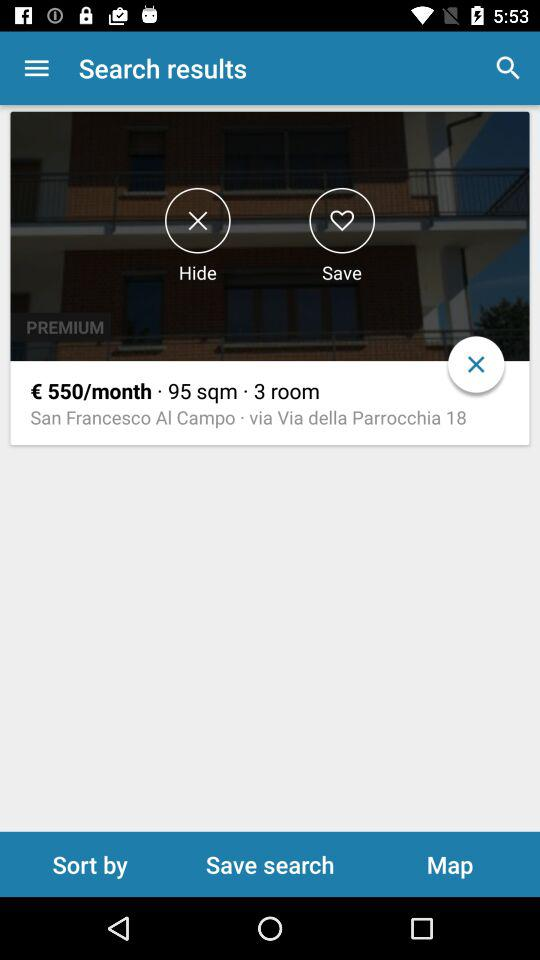How many rooms does the apartment have?
Answer the question using a single word or phrase. 3 